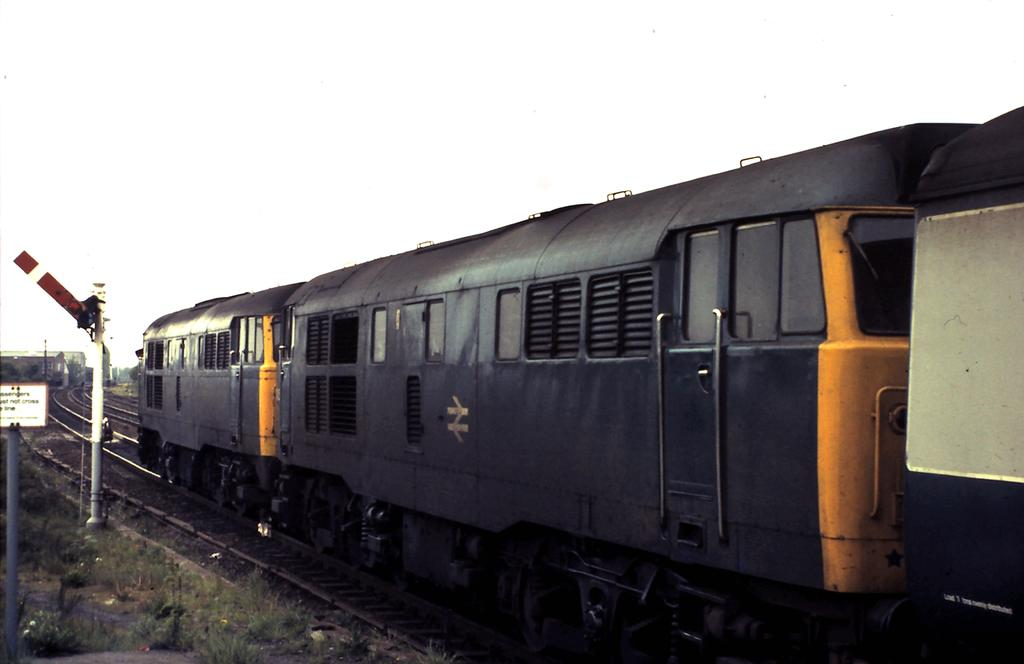What is the main subject of the image? The main subject of the image is a train on a track. What other objects can be seen in the image? There are poles and a board visible in the image. What type of vegetation is present in the image? There is grass visible in the image. What can be seen in the background of the image? In the background of the image, there is a pole, a shed, and the sky. What type of paper is the cub using to express its anger in the image? There is no paper or cub present in the image, and therefore no such activity can be observed. 